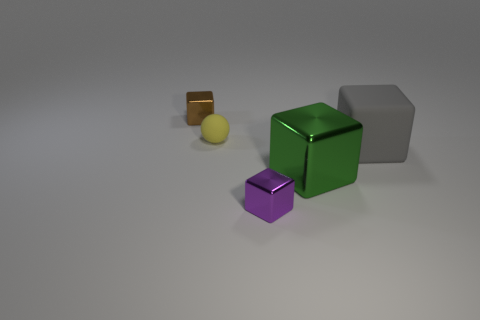Can you describe the lighting and atmosphere of the scene? The image portrays a soft, diffused lighting environment, with shadows indicating a light source that seems to be located above the objects. There are no harsh shadows or bright highlights, suggesting indirect and uniform illumination. The atmosphere feels quite neutral and sterile, reminiscent of a controlled setting like a studio. 